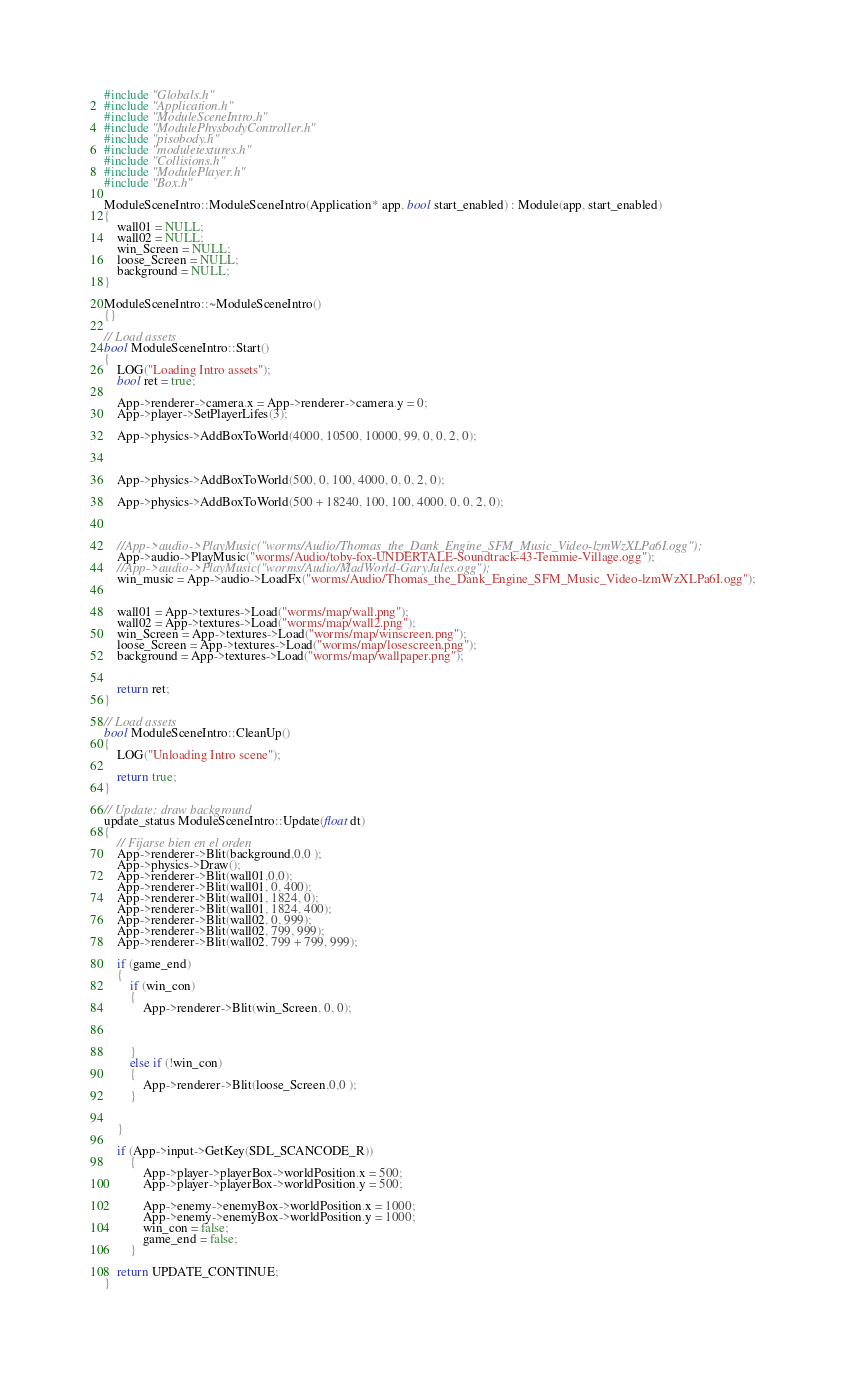<code> <loc_0><loc_0><loc_500><loc_500><_C++_>#include "Globals.h"
#include "Application.h"
#include "ModuleSceneIntro.h"
#include "ModulePhysbodyController.h"
#include "pisobody.h"
#include "moduletextures.h"
#include "Collisions.h"
#include "ModulePlayer.h"
#include "Box.h"

ModuleSceneIntro::ModuleSceneIntro(Application* app, bool start_enabled) : Module(app, start_enabled)
{
	wall01 = NULL;
	wall02 = NULL;
	win_Screen = NULL;
	loose_Screen = NULL;
	background = NULL;
}

ModuleSceneIntro::~ModuleSceneIntro()
{}

// Load assets
bool ModuleSceneIntro::Start()
{
	LOG("Loading Intro assets");
	bool ret = true;

	App->renderer->camera.x = App->renderer->camera.y = 0;
	App->player->SetPlayerLifes(3);

	App->physics->AddBoxToWorld(4000, 10500, 10000, 99, 0, 0, 2, 0);
	


	App->physics->AddBoxToWorld(500, 0, 100, 4000, 0, 0, 2, 0);

	App->physics->AddBoxToWorld(500 + 18240, 100, 100, 4000, 0, 0, 2, 0);

	

	//App->audio->PlayMusic("worms/Audio/Thomas_the_Dank_Engine_SFM_Music_Video-lzmWzXLPa6I.ogg");
	App->audio->PlayMusic("worms/Audio/toby-fox-UNDERTALE-Soundtrack-43-Temmie-Village.ogg");
	//App->audio->PlayMusic("worms/Audio/MadWorld-GaryJules.ogg");
	win_music = App->audio->LoadFx("worms/Audio/Thomas_the_Dank_Engine_SFM_Music_Video-lzmWzXLPa6I.ogg");


	wall01 = App->textures->Load("worms/map/wall.png");
	wall02 = App->textures->Load("worms/map/wall2.png");
	win_Screen = App->textures->Load("worms/map/winscreen.png");
	loose_Screen = App->textures->Load("worms/map/losescreen.png");
	background = App->textures->Load("worms/map/wallpaper.png");


	return ret;
}

// Load assets
bool ModuleSceneIntro::CleanUp()
{
	LOG("Unloading Intro scene");

	return true;
}

// Update: draw background
update_status ModuleSceneIntro::Update(float dt)
{
	// Fijarse bien en el orden
	App->renderer->Blit(background,0,0 );
	App->physics->Draw();
	App->renderer->Blit(wall01,0,0);
	App->renderer->Blit(wall01, 0, 400);
	App->renderer->Blit(wall01, 1824, 0);
	App->renderer->Blit(wall01, 1824, 400);
	App->renderer->Blit(wall02, 0, 999);
	App->renderer->Blit(wall02, 799, 999);
	App->renderer->Blit(wall02, 799 + 799, 999);
	
	if (game_end)
	{
		if (win_con)
		{
			App->renderer->Blit(win_Screen, 0, 0);
			
			
			
		}
		else if (!win_con)
		{
			App->renderer->Blit(loose_Screen,0,0 );
		}

		
	}
	
	if (App->input->GetKey(SDL_SCANCODE_R))
		{
			App->player->playerBox->worldPosition.x = 500;
			App->player->playerBox->worldPosition.y = 500;

			App->enemy->enemyBox->worldPosition.x = 1000;
			App->enemy->enemyBox->worldPosition.y = 1000;
			win_con = false;
			game_end = false;
		}

	return UPDATE_CONTINUE;
}</code> 